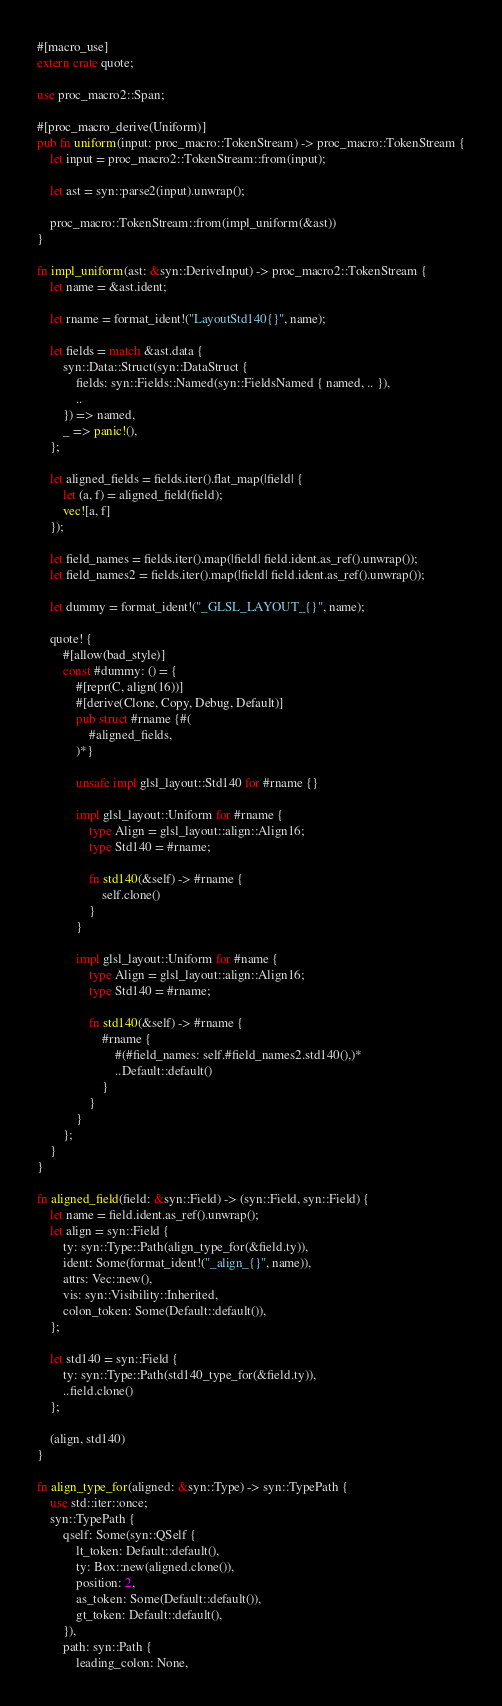Convert code to text. <code><loc_0><loc_0><loc_500><loc_500><_Rust_>#[macro_use]
extern crate quote;

use proc_macro2::Span;

#[proc_macro_derive(Uniform)]
pub fn uniform(input: proc_macro::TokenStream) -> proc_macro::TokenStream {
    let input = proc_macro2::TokenStream::from(input);

    let ast = syn::parse2(input).unwrap();

    proc_macro::TokenStream::from(impl_uniform(&ast))
}

fn impl_uniform(ast: &syn::DeriveInput) -> proc_macro2::TokenStream {
    let name = &ast.ident;

    let rname = format_ident!("LayoutStd140{}", name);

    let fields = match &ast.data {
        syn::Data::Struct(syn::DataStruct {
            fields: syn::Fields::Named(syn::FieldsNamed { named, .. }),
            ..
        }) => named,
        _ => panic!(),
    };

    let aligned_fields = fields.iter().flat_map(|field| {
        let (a, f) = aligned_field(field);
        vec![a, f]
    });

    let field_names = fields.iter().map(|field| field.ident.as_ref().unwrap());
    let field_names2 = fields.iter().map(|field| field.ident.as_ref().unwrap());

    let dummy = format_ident!("_GLSL_LAYOUT_{}", name);

    quote! {
        #[allow(bad_style)]
        const #dummy: () = {
            #[repr(C, align(16))]
            #[derive(Clone, Copy, Debug, Default)]
            pub struct #rname {#(
                #aligned_fields,
            )*}

            unsafe impl glsl_layout::Std140 for #rname {}

            impl glsl_layout::Uniform for #rname {
                type Align = glsl_layout::align::Align16;
                type Std140 = #rname;

                fn std140(&self) -> #rname {
                    self.clone()
                }
            }

            impl glsl_layout::Uniform for #name {
                type Align = glsl_layout::align::Align16;
                type Std140 = #rname;

                fn std140(&self) -> #rname {
                    #rname {
                        #(#field_names: self.#field_names2.std140(),)*
                        ..Default::default()
                    }
                }
            }
        };
    }
}

fn aligned_field(field: &syn::Field) -> (syn::Field, syn::Field) {
    let name = field.ident.as_ref().unwrap();
    let align = syn::Field {
        ty: syn::Type::Path(align_type_for(&field.ty)),
        ident: Some(format_ident!("_align_{}", name)),
        attrs: Vec::new(),
        vis: syn::Visibility::Inherited,
        colon_token: Some(Default::default()),
    };

    let std140 = syn::Field {
        ty: syn::Type::Path(std140_type_for(&field.ty)),
        ..field.clone()
    };

    (align, std140)
}

fn align_type_for(aligned: &syn::Type) -> syn::TypePath {
    use std::iter::once;
    syn::TypePath {
        qself: Some(syn::QSelf {
            lt_token: Default::default(),
            ty: Box::new(aligned.clone()),
            position: 2,
            as_token: Some(Default::default()),
            gt_token: Default::default(),
        }),
        path: syn::Path {
            leading_colon: None,</code> 